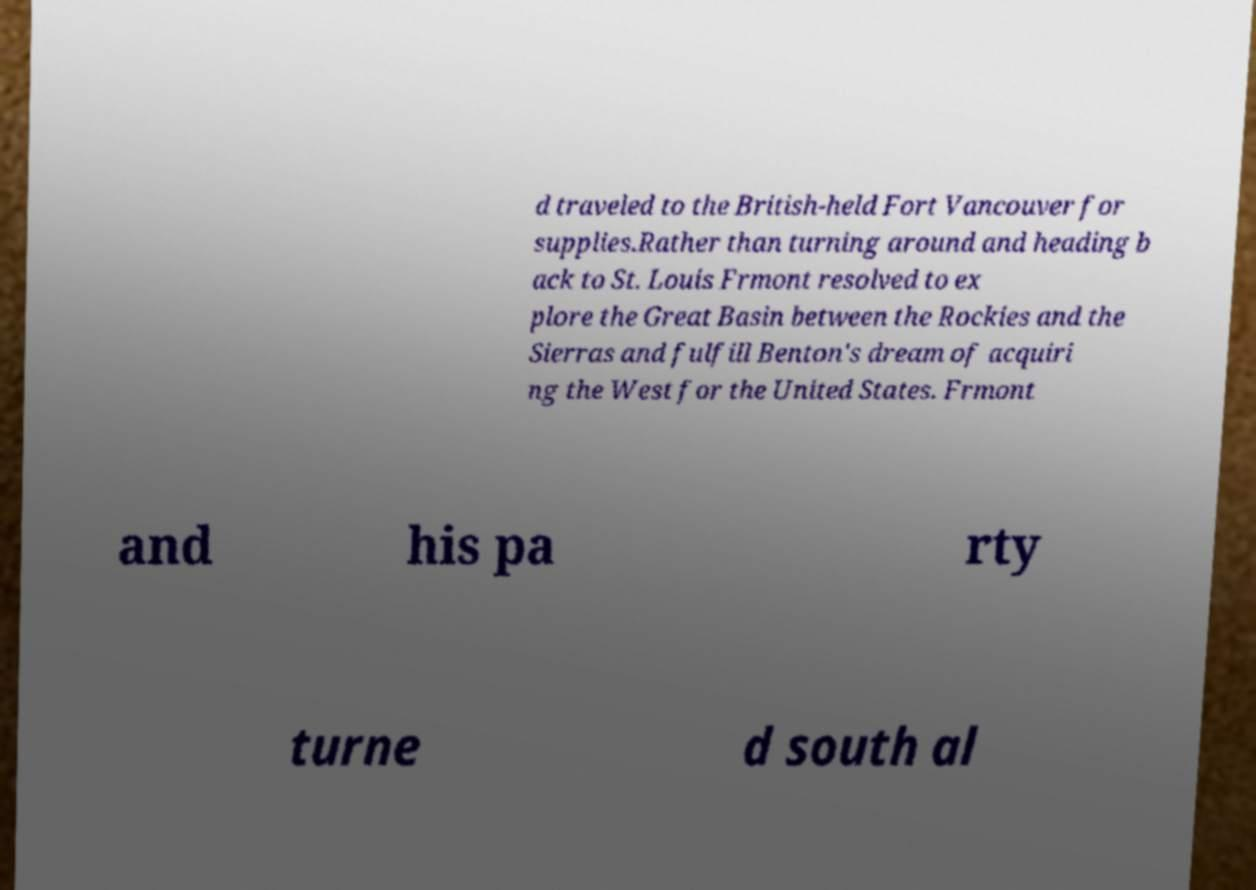I need the written content from this picture converted into text. Can you do that? d traveled to the British-held Fort Vancouver for supplies.Rather than turning around and heading b ack to St. Louis Frmont resolved to ex plore the Great Basin between the Rockies and the Sierras and fulfill Benton's dream of acquiri ng the West for the United States. Frmont and his pa rty turne d south al 